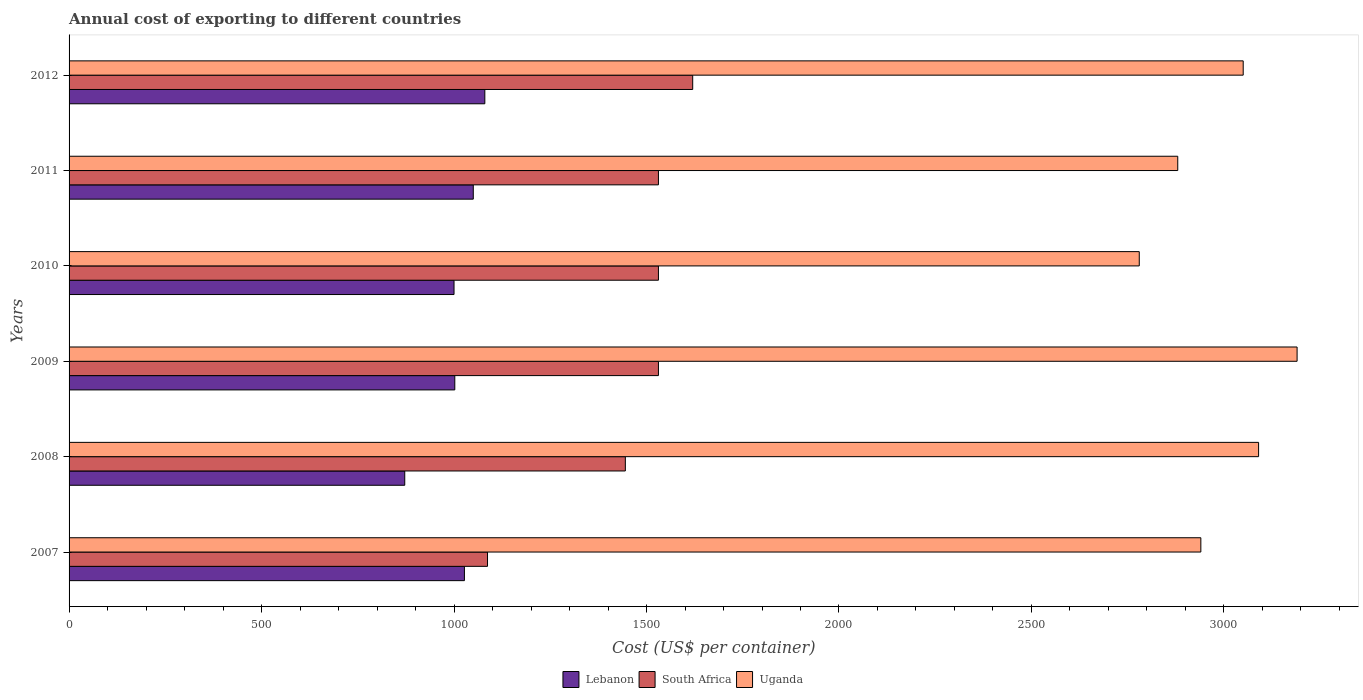How many groups of bars are there?
Your answer should be compact. 6. Are the number of bars on each tick of the Y-axis equal?
Provide a succinct answer. Yes. How many bars are there on the 6th tick from the top?
Provide a succinct answer. 3. How many bars are there on the 5th tick from the bottom?
Your answer should be very brief. 3. What is the total annual cost of exporting in South Africa in 2011?
Offer a very short reply. 1531. Across all years, what is the maximum total annual cost of exporting in Uganda?
Give a very brief answer. 3190. Across all years, what is the minimum total annual cost of exporting in Lebanon?
Provide a succinct answer. 872. What is the total total annual cost of exporting in South Africa in the graph?
Your answer should be compact. 8745. What is the difference between the total annual cost of exporting in Lebanon in 2007 and that in 2010?
Provide a short and direct response. 27. What is the difference between the total annual cost of exporting in Lebanon in 2010 and the total annual cost of exporting in South Africa in 2009?
Provide a short and direct response. -531. What is the average total annual cost of exporting in Uganda per year?
Provide a short and direct response. 2988.33. In the year 2010, what is the difference between the total annual cost of exporting in South Africa and total annual cost of exporting in Uganda?
Your answer should be very brief. -1249. In how many years, is the total annual cost of exporting in South Africa greater than 700 US$?
Your answer should be compact. 6. Is the total annual cost of exporting in Uganda in 2008 less than that in 2010?
Provide a short and direct response. No. What is the difference between the highest and the second highest total annual cost of exporting in Uganda?
Offer a terse response. 100. What is the difference between the highest and the lowest total annual cost of exporting in South Africa?
Give a very brief answer. 533. In how many years, is the total annual cost of exporting in Lebanon greater than the average total annual cost of exporting in Lebanon taken over all years?
Offer a very short reply. 3. What does the 2nd bar from the top in 2007 represents?
Ensure brevity in your answer.  South Africa. What does the 1st bar from the bottom in 2012 represents?
Give a very brief answer. Lebanon. How many bars are there?
Give a very brief answer. 18. Are all the bars in the graph horizontal?
Your answer should be very brief. Yes. How many years are there in the graph?
Provide a succinct answer. 6. What is the difference between two consecutive major ticks on the X-axis?
Your response must be concise. 500. Are the values on the major ticks of X-axis written in scientific E-notation?
Give a very brief answer. No. Does the graph contain grids?
Your answer should be compact. No. How are the legend labels stacked?
Offer a terse response. Horizontal. What is the title of the graph?
Provide a short and direct response. Annual cost of exporting to different countries. Does "Kuwait" appear as one of the legend labels in the graph?
Your answer should be compact. No. What is the label or title of the X-axis?
Your answer should be compact. Cost (US$ per container). What is the label or title of the Y-axis?
Your answer should be compact. Years. What is the Cost (US$ per container) of Lebanon in 2007?
Offer a terse response. 1027. What is the Cost (US$ per container) of South Africa in 2007?
Provide a short and direct response. 1087. What is the Cost (US$ per container) of Uganda in 2007?
Make the answer very short. 2940. What is the Cost (US$ per container) in Lebanon in 2008?
Your response must be concise. 872. What is the Cost (US$ per container) of South Africa in 2008?
Keep it short and to the point. 1445. What is the Cost (US$ per container) in Uganda in 2008?
Offer a terse response. 3090. What is the Cost (US$ per container) in Lebanon in 2009?
Make the answer very short. 1002. What is the Cost (US$ per container) in South Africa in 2009?
Provide a succinct answer. 1531. What is the Cost (US$ per container) of Uganda in 2009?
Ensure brevity in your answer.  3190. What is the Cost (US$ per container) of South Africa in 2010?
Provide a succinct answer. 1531. What is the Cost (US$ per container) in Uganda in 2010?
Your answer should be very brief. 2780. What is the Cost (US$ per container) in Lebanon in 2011?
Make the answer very short. 1050. What is the Cost (US$ per container) in South Africa in 2011?
Your answer should be very brief. 1531. What is the Cost (US$ per container) in Uganda in 2011?
Offer a very short reply. 2880. What is the Cost (US$ per container) of Lebanon in 2012?
Ensure brevity in your answer.  1080. What is the Cost (US$ per container) of South Africa in 2012?
Keep it short and to the point. 1620. What is the Cost (US$ per container) in Uganda in 2012?
Make the answer very short. 3050. Across all years, what is the maximum Cost (US$ per container) of Lebanon?
Ensure brevity in your answer.  1080. Across all years, what is the maximum Cost (US$ per container) of South Africa?
Offer a very short reply. 1620. Across all years, what is the maximum Cost (US$ per container) of Uganda?
Give a very brief answer. 3190. Across all years, what is the minimum Cost (US$ per container) of Lebanon?
Offer a terse response. 872. Across all years, what is the minimum Cost (US$ per container) of South Africa?
Make the answer very short. 1087. Across all years, what is the minimum Cost (US$ per container) in Uganda?
Provide a short and direct response. 2780. What is the total Cost (US$ per container) in Lebanon in the graph?
Your answer should be very brief. 6031. What is the total Cost (US$ per container) of South Africa in the graph?
Provide a short and direct response. 8745. What is the total Cost (US$ per container) in Uganda in the graph?
Keep it short and to the point. 1.79e+04. What is the difference between the Cost (US$ per container) of Lebanon in 2007 and that in 2008?
Offer a very short reply. 155. What is the difference between the Cost (US$ per container) in South Africa in 2007 and that in 2008?
Make the answer very short. -358. What is the difference between the Cost (US$ per container) in Uganda in 2007 and that in 2008?
Make the answer very short. -150. What is the difference between the Cost (US$ per container) in South Africa in 2007 and that in 2009?
Your response must be concise. -444. What is the difference between the Cost (US$ per container) in Uganda in 2007 and that in 2009?
Provide a short and direct response. -250. What is the difference between the Cost (US$ per container) of South Africa in 2007 and that in 2010?
Ensure brevity in your answer.  -444. What is the difference between the Cost (US$ per container) in Uganda in 2007 and that in 2010?
Keep it short and to the point. 160. What is the difference between the Cost (US$ per container) in Lebanon in 2007 and that in 2011?
Offer a very short reply. -23. What is the difference between the Cost (US$ per container) of South Africa in 2007 and that in 2011?
Make the answer very short. -444. What is the difference between the Cost (US$ per container) of Uganda in 2007 and that in 2011?
Provide a succinct answer. 60. What is the difference between the Cost (US$ per container) of Lebanon in 2007 and that in 2012?
Your answer should be very brief. -53. What is the difference between the Cost (US$ per container) in South Africa in 2007 and that in 2012?
Your answer should be compact. -533. What is the difference between the Cost (US$ per container) in Uganda in 2007 and that in 2012?
Make the answer very short. -110. What is the difference between the Cost (US$ per container) of Lebanon in 2008 and that in 2009?
Keep it short and to the point. -130. What is the difference between the Cost (US$ per container) of South Africa in 2008 and that in 2009?
Provide a succinct answer. -86. What is the difference between the Cost (US$ per container) of Uganda in 2008 and that in 2009?
Ensure brevity in your answer.  -100. What is the difference between the Cost (US$ per container) in Lebanon in 2008 and that in 2010?
Provide a short and direct response. -128. What is the difference between the Cost (US$ per container) of South Africa in 2008 and that in 2010?
Give a very brief answer. -86. What is the difference between the Cost (US$ per container) of Uganda in 2008 and that in 2010?
Your answer should be very brief. 310. What is the difference between the Cost (US$ per container) in Lebanon in 2008 and that in 2011?
Keep it short and to the point. -178. What is the difference between the Cost (US$ per container) in South Africa in 2008 and that in 2011?
Provide a short and direct response. -86. What is the difference between the Cost (US$ per container) in Uganda in 2008 and that in 2011?
Your response must be concise. 210. What is the difference between the Cost (US$ per container) of Lebanon in 2008 and that in 2012?
Offer a terse response. -208. What is the difference between the Cost (US$ per container) in South Africa in 2008 and that in 2012?
Offer a terse response. -175. What is the difference between the Cost (US$ per container) of South Africa in 2009 and that in 2010?
Ensure brevity in your answer.  0. What is the difference between the Cost (US$ per container) of Uganda in 2009 and that in 2010?
Make the answer very short. 410. What is the difference between the Cost (US$ per container) of Lebanon in 2009 and that in 2011?
Give a very brief answer. -48. What is the difference between the Cost (US$ per container) in Uganda in 2009 and that in 2011?
Give a very brief answer. 310. What is the difference between the Cost (US$ per container) of Lebanon in 2009 and that in 2012?
Provide a short and direct response. -78. What is the difference between the Cost (US$ per container) of South Africa in 2009 and that in 2012?
Provide a short and direct response. -89. What is the difference between the Cost (US$ per container) in Uganda in 2009 and that in 2012?
Give a very brief answer. 140. What is the difference between the Cost (US$ per container) of Lebanon in 2010 and that in 2011?
Provide a succinct answer. -50. What is the difference between the Cost (US$ per container) in Uganda in 2010 and that in 2011?
Your answer should be compact. -100. What is the difference between the Cost (US$ per container) of Lebanon in 2010 and that in 2012?
Give a very brief answer. -80. What is the difference between the Cost (US$ per container) of South Africa in 2010 and that in 2012?
Your answer should be compact. -89. What is the difference between the Cost (US$ per container) of Uganda in 2010 and that in 2012?
Your answer should be compact. -270. What is the difference between the Cost (US$ per container) of South Africa in 2011 and that in 2012?
Ensure brevity in your answer.  -89. What is the difference between the Cost (US$ per container) of Uganda in 2011 and that in 2012?
Offer a very short reply. -170. What is the difference between the Cost (US$ per container) of Lebanon in 2007 and the Cost (US$ per container) of South Africa in 2008?
Make the answer very short. -418. What is the difference between the Cost (US$ per container) of Lebanon in 2007 and the Cost (US$ per container) of Uganda in 2008?
Keep it short and to the point. -2063. What is the difference between the Cost (US$ per container) of South Africa in 2007 and the Cost (US$ per container) of Uganda in 2008?
Keep it short and to the point. -2003. What is the difference between the Cost (US$ per container) of Lebanon in 2007 and the Cost (US$ per container) of South Africa in 2009?
Provide a short and direct response. -504. What is the difference between the Cost (US$ per container) in Lebanon in 2007 and the Cost (US$ per container) in Uganda in 2009?
Provide a succinct answer. -2163. What is the difference between the Cost (US$ per container) in South Africa in 2007 and the Cost (US$ per container) in Uganda in 2009?
Ensure brevity in your answer.  -2103. What is the difference between the Cost (US$ per container) of Lebanon in 2007 and the Cost (US$ per container) of South Africa in 2010?
Your answer should be compact. -504. What is the difference between the Cost (US$ per container) of Lebanon in 2007 and the Cost (US$ per container) of Uganda in 2010?
Give a very brief answer. -1753. What is the difference between the Cost (US$ per container) of South Africa in 2007 and the Cost (US$ per container) of Uganda in 2010?
Ensure brevity in your answer.  -1693. What is the difference between the Cost (US$ per container) of Lebanon in 2007 and the Cost (US$ per container) of South Africa in 2011?
Your answer should be compact. -504. What is the difference between the Cost (US$ per container) in Lebanon in 2007 and the Cost (US$ per container) in Uganda in 2011?
Give a very brief answer. -1853. What is the difference between the Cost (US$ per container) of South Africa in 2007 and the Cost (US$ per container) of Uganda in 2011?
Make the answer very short. -1793. What is the difference between the Cost (US$ per container) in Lebanon in 2007 and the Cost (US$ per container) in South Africa in 2012?
Offer a very short reply. -593. What is the difference between the Cost (US$ per container) in Lebanon in 2007 and the Cost (US$ per container) in Uganda in 2012?
Your answer should be very brief. -2023. What is the difference between the Cost (US$ per container) in South Africa in 2007 and the Cost (US$ per container) in Uganda in 2012?
Offer a terse response. -1963. What is the difference between the Cost (US$ per container) in Lebanon in 2008 and the Cost (US$ per container) in South Africa in 2009?
Your answer should be very brief. -659. What is the difference between the Cost (US$ per container) in Lebanon in 2008 and the Cost (US$ per container) in Uganda in 2009?
Provide a short and direct response. -2318. What is the difference between the Cost (US$ per container) in South Africa in 2008 and the Cost (US$ per container) in Uganda in 2009?
Your response must be concise. -1745. What is the difference between the Cost (US$ per container) of Lebanon in 2008 and the Cost (US$ per container) of South Africa in 2010?
Your answer should be very brief. -659. What is the difference between the Cost (US$ per container) in Lebanon in 2008 and the Cost (US$ per container) in Uganda in 2010?
Your answer should be compact. -1908. What is the difference between the Cost (US$ per container) of South Africa in 2008 and the Cost (US$ per container) of Uganda in 2010?
Offer a terse response. -1335. What is the difference between the Cost (US$ per container) of Lebanon in 2008 and the Cost (US$ per container) of South Africa in 2011?
Provide a short and direct response. -659. What is the difference between the Cost (US$ per container) of Lebanon in 2008 and the Cost (US$ per container) of Uganda in 2011?
Ensure brevity in your answer.  -2008. What is the difference between the Cost (US$ per container) of South Africa in 2008 and the Cost (US$ per container) of Uganda in 2011?
Your response must be concise. -1435. What is the difference between the Cost (US$ per container) of Lebanon in 2008 and the Cost (US$ per container) of South Africa in 2012?
Keep it short and to the point. -748. What is the difference between the Cost (US$ per container) in Lebanon in 2008 and the Cost (US$ per container) in Uganda in 2012?
Ensure brevity in your answer.  -2178. What is the difference between the Cost (US$ per container) in South Africa in 2008 and the Cost (US$ per container) in Uganda in 2012?
Your answer should be compact. -1605. What is the difference between the Cost (US$ per container) of Lebanon in 2009 and the Cost (US$ per container) of South Africa in 2010?
Offer a terse response. -529. What is the difference between the Cost (US$ per container) of Lebanon in 2009 and the Cost (US$ per container) of Uganda in 2010?
Provide a short and direct response. -1778. What is the difference between the Cost (US$ per container) of South Africa in 2009 and the Cost (US$ per container) of Uganda in 2010?
Ensure brevity in your answer.  -1249. What is the difference between the Cost (US$ per container) of Lebanon in 2009 and the Cost (US$ per container) of South Africa in 2011?
Ensure brevity in your answer.  -529. What is the difference between the Cost (US$ per container) of Lebanon in 2009 and the Cost (US$ per container) of Uganda in 2011?
Offer a terse response. -1878. What is the difference between the Cost (US$ per container) in South Africa in 2009 and the Cost (US$ per container) in Uganda in 2011?
Give a very brief answer. -1349. What is the difference between the Cost (US$ per container) of Lebanon in 2009 and the Cost (US$ per container) of South Africa in 2012?
Keep it short and to the point. -618. What is the difference between the Cost (US$ per container) of Lebanon in 2009 and the Cost (US$ per container) of Uganda in 2012?
Offer a very short reply. -2048. What is the difference between the Cost (US$ per container) of South Africa in 2009 and the Cost (US$ per container) of Uganda in 2012?
Keep it short and to the point. -1519. What is the difference between the Cost (US$ per container) of Lebanon in 2010 and the Cost (US$ per container) of South Africa in 2011?
Provide a succinct answer. -531. What is the difference between the Cost (US$ per container) in Lebanon in 2010 and the Cost (US$ per container) in Uganda in 2011?
Your response must be concise. -1880. What is the difference between the Cost (US$ per container) of South Africa in 2010 and the Cost (US$ per container) of Uganda in 2011?
Give a very brief answer. -1349. What is the difference between the Cost (US$ per container) in Lebanon in 2010 and the Cost (US$ per container) in South Africa in 2012?
Ensure brevity in your answer.  -620. What is the difference between the Cost (US$ per container) in Lebanon in 2010 and the Cost (US$ per container) in Uganda in 2012?
Offer a terse response. -2050. What is the difference between the Cost (US$ per container) in South Africa in 2010 and the Cost (US$ per container) in Uganda in 2012?
Provide a succinct answer. -1519. What is the difference between the Cost (US$ per container) of Lebanon in 2011 and the Cost (US$ per container) of South Africa in 2012?
Your answer should be very brief. -570. What is the difference between the Cost (US$ per container) of Lebanon in 2011 and the Cost (US$ per container) of Uganda in 2012?
Your answer should be very brief. -2000. What is the difference between the Cost (US$ per container) in South Africa in 2011 and the Cost (US$ per container) in Uganda in 2012?
Offer a terse response. -1519. What is the average Cost (US$ per container) of Lebanon per year?
Your answer should be very brief. 1005.17. What is the average Cost (US$ per container) of South Africa per year?
Offer a very short reply. 1457.5. What is the average Cost (US$ per container) of Uganda per year?
Ensure brevity in your answer.  2988.33. In the year 2007, what is the difference between the Cost (US$ per container) in Lebanon and Cost (US$ per container) in South Africa?
Provide a succinct answer. -60. In the year 2007, what is the difference between the Cost (US$ per container) of Lebanon and Cost (US$ per container) of Uganda?
Make the answer very short. -1913. In the year 2007, what is the difference between the Cost (US$ per container) of South Africa and Cost (US$ per container) of Uganda?
Give a very brief answer. -1853. In the year 2008, what is the difference between the Cost (US$ per container) of Lebanon and Cost (US$ per container) of South Africa?
Your answer should be very brief. -573. In the year 2008, what is the difference between the Cost (US$ per container) in Lebanon and Cost (US$ per container) in Uganda?
Offer a very short reply. -2218. In the year 2008, what is the difference between the Cost (US$ per container) in South Africa and Cost (US$ per container) in Uganda?
Your response must be concise. -1645. In the year 2009, what is the difference between the Cost (US$ per container) of Lebanon and Cost (US$ per container) of South Africa?
Your answer should be very brief. -529. In the year 2009, what is the difference between the Cost (US$ per container) in Lebanon and Cost (US$ per container) in Uganda?
Your answer should be compact. -2188. In the year 2009, what is the difference between the Cost (US$ per container) of South Africa and Cost (US$ per container) of Uganda?
Ensure brevity in your answer.  -1659. In the year 2010, what is the difference between the Cost (US$ per container) of Lebanon and Cost (US$ per container) of South Africa?
Your answer should be very brief. -531. In the year 2010, what is the difference between the Cost (US$ per container) in Lebanon and Cost (US$ per container) in Uganda?
Your answer should be compact. -1780. In the year 2010, what is the difference between the Cost (US$ per container) in South Africa and Cost (US$ per container) in Uganda?
Give a very brief answer. -1249. In the year 2011, what is the difference between the Cost (US$ per container) of Lebanon and Cost (US$ per container) of South Africa?
Provide a succinct answer. -481. In the year 2011, what is the difference between the Cost (US$ per container) in Lebanon and Cost (US$ per container) in Uganda?
Make the answer very short. -1830. In the year 2011, what is the difference between the Cost (US$ per container) in South Africa and Cost (US$ per container) in Uganda?
Ensure brevity in your answer.  -1349. In the year 2012, what is the difference between the Cost (US$ per container) in Lebanon and Cost (US$ per container) in South Africa?
Ensure brevity in your answer.  -540. In the year 2012, what is the difference between the Cost (US$ per container) of Lebanon and Cost (US$ per container) of Uganda?
Keep it short and to the point. -1970. In the year 2012, what is the difference between the Cost (US$ per container) of South Africa and Cost (US$ per container) of Uganda?
Ensure brevity in your answer.  -1430. What is the ratio of the Cost (US$ per container) in Lebanon in 2007 to that in 2008?
Make the answer very short. 1.18. What is the ratio of the Cost (US$ per container) in South Africa in 2007 to that in 2008?
Give a very brief answer. 0.75. What is the ratio of the Cost (US$ per container) in Uganda in 2007 to that in 2008?
Offer a terse response. 0.95. What is the ratio of the Cost (US$ per container) of Lebanon in 2007 to that in 2009?
Keep it short and to the point. 1.02. What is the ratio of the Cost (US$ per container) in South Africa in 2007 to that in 2009?
Your response must be concise. 0.71. What is the ratio of the Cost (US$ per container) in Uganda in 2007 to that in 2009?
Your answer should be very brief. 0.92. What is the ratio of the Cost (US$ per container) of South Africa in 2007 to that in 2010?
Ensure brevity in your answer.  0.71. What is the ratio of the Cost (US$ per container) of Uganda in 2007 to that in 2010?
Your answer should be compact. 1.06. What is the ratio of the Cost (US$ per container) in Lebanon in 2007 to that in 2011?
Your answer should be compact. 0.98. What is the ratio of the Cost (US$ per container) of South Africa in 2007 to that in 2011?
Offer a terse response. 0.71. What is the ratio of the Cost (US$ per container) in Uganda in 2007 to that in 2011?
Keep it short and to the point. 1.02. What is the ratio of the Cost (US$ per container) in Lebanon in 2007 to that in 2012?
Keep it short and to the point. 0.95. What is the ratio of the Cost (US$ per container) in South Africa in 2007 to that in 2012?
Your response must be concise. 0.67. What is the ratio of the Cost (US$ per container) in Uganda in 2007 to that in 2012?
Provide a short and direct response. 0.96. What is the ratio of the Cost (US$ per container) in Lebanon in 2008 to that in 2009?
Your answer should be compact. 0.87. What is the ratio of the Cost (US$ per container) of South Africa in 2008 to that in 2009?
Provide a succinct answer. 0.94. What is the ratio of the Cost (US$ per container) of Uganda in 2008 to that in 2009?
Your response must be concise. 0.97. What is the ratio of the Cost (US$ per container) in Lebanon in 2008 to that in 2010?
Give a very brief answer. 0.87. What is the ratio of the Cost (US$ per container) in South Africa in 2008 to that in 2010?
Your answer should be compact. 0.94. What is the ratio of the Cost (US$ per container) in Uganda in 2008 to that in 2010?
Make the answer very short. 1.11. What is the ratio of the Cost (US$ per container) in Lebanon in 2008 to that in 2011?
Your answer should be very brief. 0.83. What is the ratio of the Cost (US$ per container) in South Africa in 2008 to that in 2011?
Your answer should be very brief. 0.94. What is the ratio of the Cost (US$ per container) of Uganda in 2008 to that in 2011?
Provide a short and direct response. 1.07. What is the ratio of the Cost (US$ per container) in Lebanon in 2008 to that in 2012?
Offer a very short reply. 0.81. What is the ratio of the Cost (US$ per container) of South Africa in 2008 to that in 2012?
Your answer should be very brief. 0.89. What is the ratio of the Cost (US$ per container) of Uganda in 2008 to that in 2012?
Ensure brevity in your answer.  1.01. What is the ratio of the Cost (US$ per container) in Lebanon in 2009 to that in 2010?
Your answer should be compact. 1. What is the ratio of the Cost (US$ per container) in Uganda in 2009 to that in 2010?
Provide a succinct answer. 1.15. What is the ratio of the Cost (US$ per container) in Lebanon in 2009 to that in 2011?
Provide a succinct answer. 0.95. What is the ratio of the Cost (US$ per container) of South Africa in 2009 to that in 2011?
Offer a very short reply. 1. What is the ratio of the Cost (US$ per container) in Uganda in 2009 to that in 2011?
Your answer should be very brief. 1.11. What is the ratio of the Cost (US$ per container) of Lebanon in 2009 to that in 2012?
Your answer should be very brief. 0.93. What is the ratio of the Cost (US$ per container) of South Africa in 2009 to that in 2012?
Give a very brief answer. 0.95. What is the ratio of the Cost (US$ per container) of Uganda in 2009 to that in 2012?
Your response must be concise. 1.05. What is the ratio of the Cost (US$ per container) of South Africa in 2010 to that in 2011?
Provide a short and direct response. 1. What is the ratio of the Cost (US$ per container) in Uganda in 2010 to that in 2011?
Provide a succinct answer. 0.97. What is the ratio of the Cost (US$ per container) in Lebanon in 2010 to that in 2012?
Offer a terse response. 0.93. What is the ratio of the Cost (US$ per container) of South Africa in 2010 to that in 2012?
Your response must be concise. 0.95. What is the ratio of the Cost (US$ per container) in Uganda in 2010 to that in 2012?
Give a very brief answer. 0.91. What is the ratio of the Cost (US$ per container) of Lebanon in 2011 to that in 2012?
Provide a succinct answer. 0.97. What is the ratio of the Cost (US$ per container) in South Africa in 2011 to that in 2012?
Your answer should be very brief. 0.95. What is the ratio of the Cost (US$ per container) in Uganda in 2011 to that in 2012?
Give a very brief answer. 0.94. What is the difference between the highest and the second highest Cost (US$ per container) in Lebanon?
Your answer should be very brief. 30. What is the difference between the highest and the second highest Cost (US$ per container) in South Africa?
Ensure brevity in your answer.  89. What is the difference between the highest and the lowest Cost (US$ per container) of Lebanon?
Make the answer very short. 208. What is the difference between the highest and the lowest Cost (US$ per container) in South Africa?
Ensure brevity in your answer.  533. What is the difference between the highest and the lowest Cost (US$ per container) of Uganda?
Give a very brief answer. 410. 